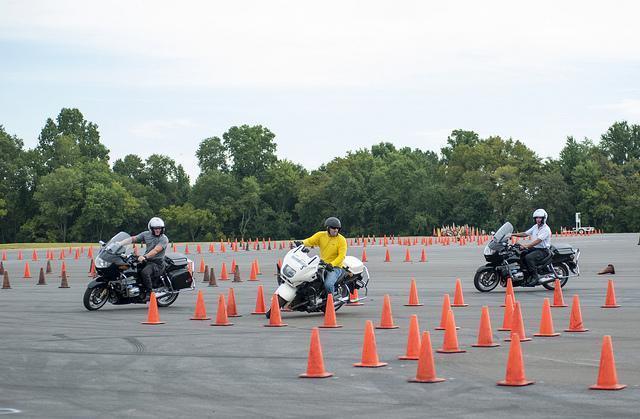How many motorcyclists are there?
Give a very brief answer. 3. How many motorcycles can you see?
Give a very brief answer. 3. How many orange slices can you see?
Give a very brief answer. 0. 